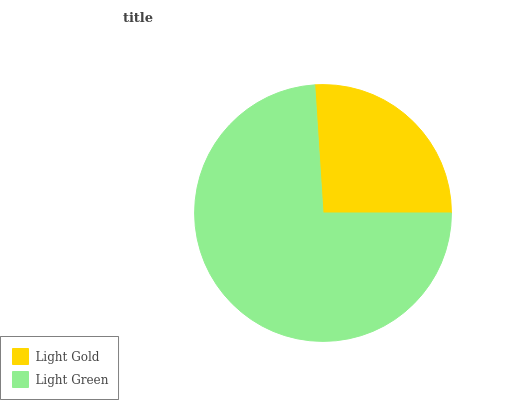Is Light Gold the minimum?
Answer yes or no. Yes. Is Light Green the maximum?
Answer yes or no. Yes. Is Light Green the minimum?
Answer yes or no. No. Is Light Green greater than Light Gold?
Answer yes or no. Yes. Is Light Gold less than Light Green?
Answer yes or no. Yes. Is Light Gold greater than Light Green?
Answer yes or no. No. Is Light Green less than Light Gold?
Answer yes or no. No. Is Light Green the high median?
Answer yes or no. Yes. Is Light Gold the low median?
Answer yes or no. Yes. Is Light Gold the high median?
Answer yes or no. No. Is Light Green the low median?
Answer yes or no. No. 